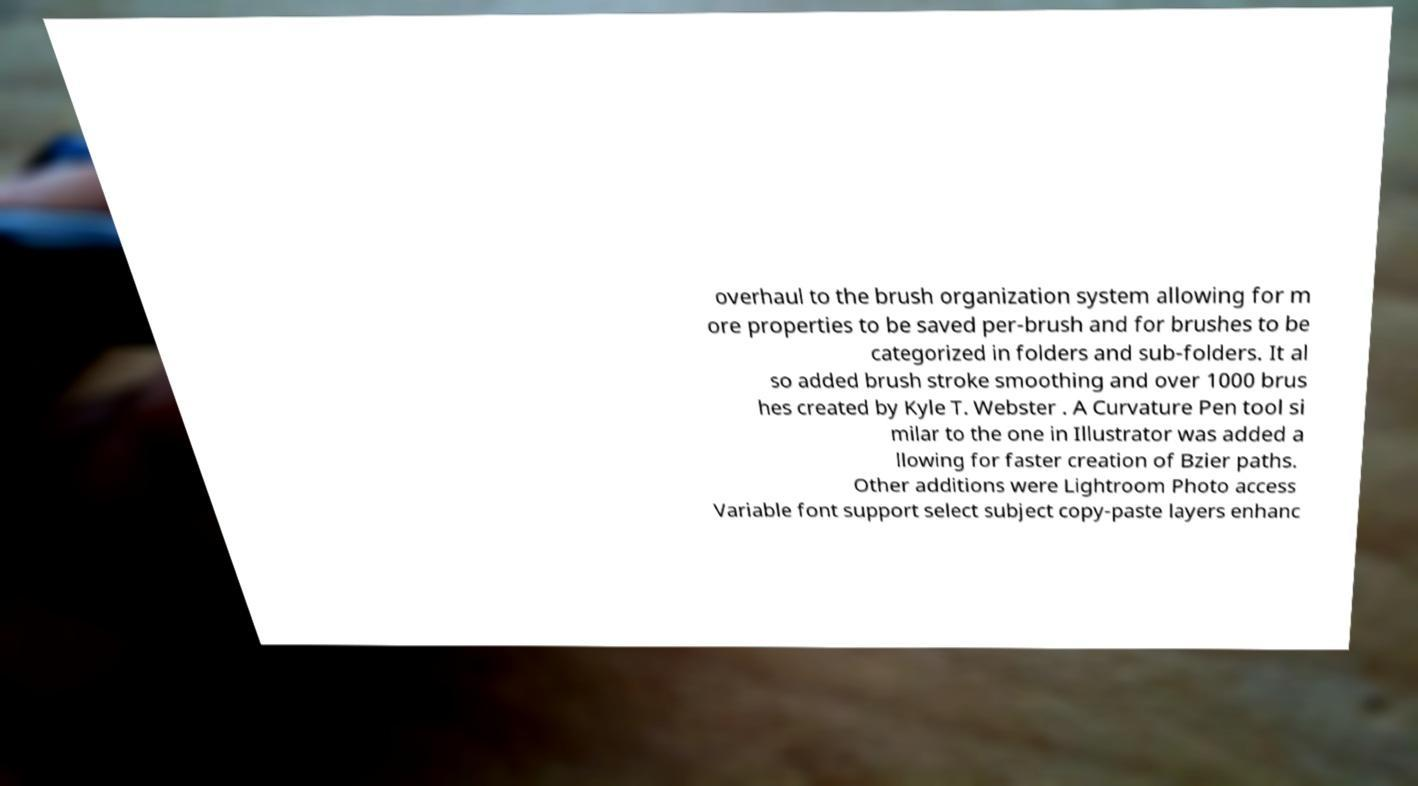Could you assist in decoding the text presented in this image and type it out clearly? overhaul to the brush organization system allowing for m ore properties to be saved per-brush and for brushes to be categorized in folders and sub-folders. It al so added brush stroke smoothing and over 1000 brus hes created by Kyle T. Webster . A Curvature Pen tool si milar to the one in Illustrator was added a llowing for faster creation of Bzier paths. Other additions were Lightroom Photo access Variable font support select subject copy-paste layers enhanc 